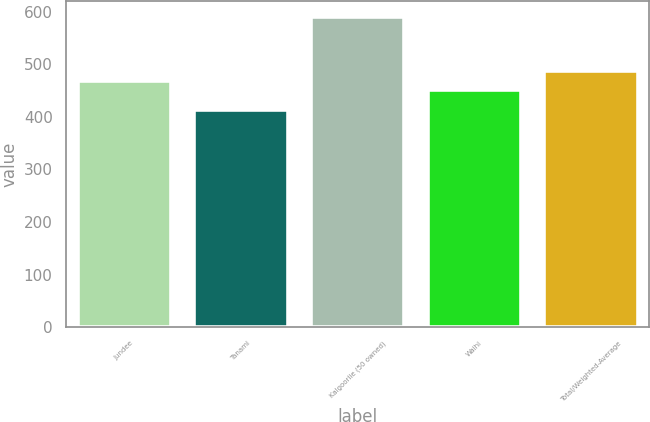Convert chart. <chart><loc_0><loc_0><loc_500><loc_500><bar_chart><fcel>Jundee<fcel>Tanami<fcel>Kalgoorlie (50 owned)<fcel>Waihi<fcel>Total/Weighted-Average<nl><fcel>468.8<fcel>413<fcel>591<fcel>451<fcel>486.6<nl></chart> 